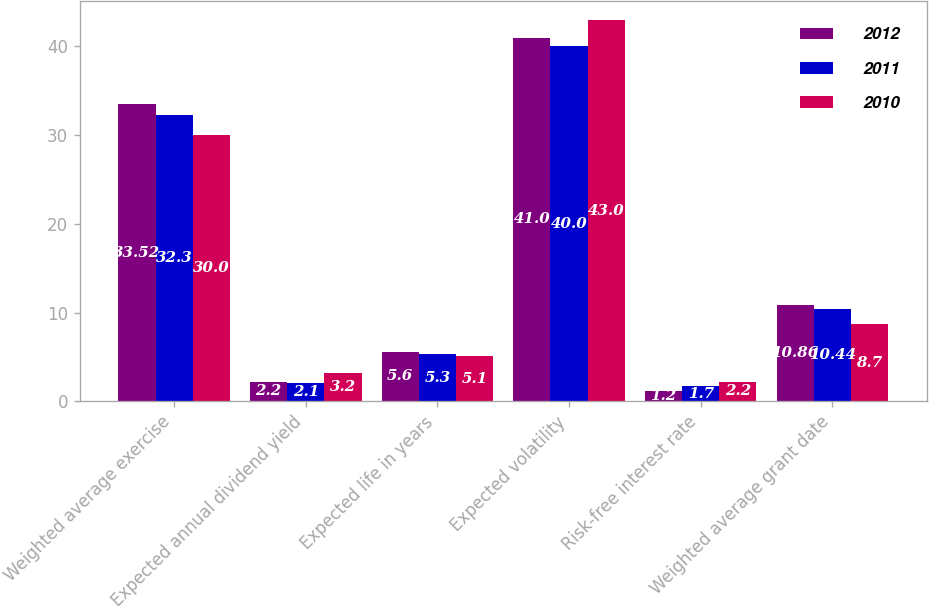Convert chart to OTSL. <chart><loc_0><loc_0><loc_500><loc_500><stacked_bar_chart><ecel><fcel>Weighted average exercise<fcel>Expected annual dividend yield<fcel>Expected life in years<fcel>Expected volatility<fcel>Risk-free interest rate<fcel>Weighted average grant date<nl><fcel>2012<fcel>33.52<fcel>2.2<fcel>5.6<fcel>41<fcel>1.2<fcel>10.86<nl><fcel>2011<fcel>32.3<fcel>2.1<fcel>5.3<fcel>40<fcel>1.7<fcel>10.44<nl><fcel>2010<fcel>30<fcel>3.2<fcel>5.1<fcel>43<fcel>2.2<fcel>8.7<nl></chart> 